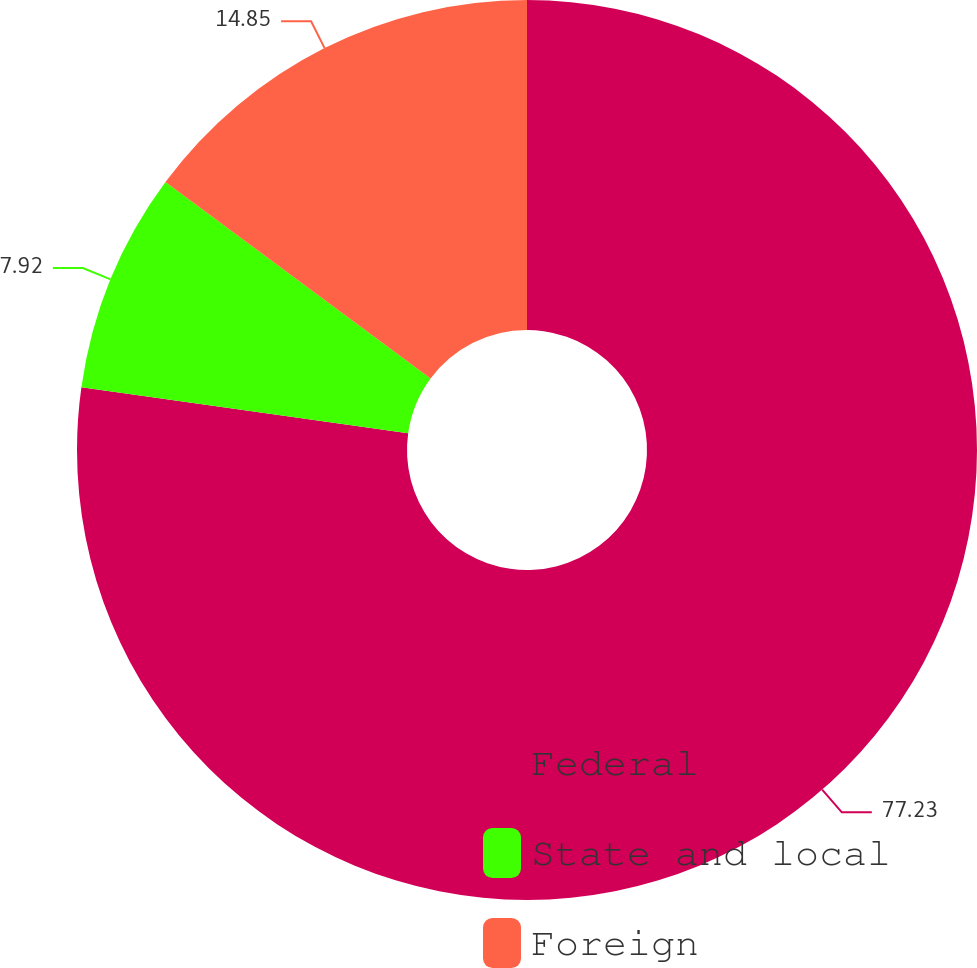Convert chart. <chart><loc_0><loc_0><loc_500><loc_500><pie_chart><fcel>Federal<fcel>State and local<fcel>Foreign<nl><fcel>77.23%<fcel>7.92%<fcel>14.85%<nl></chart> 